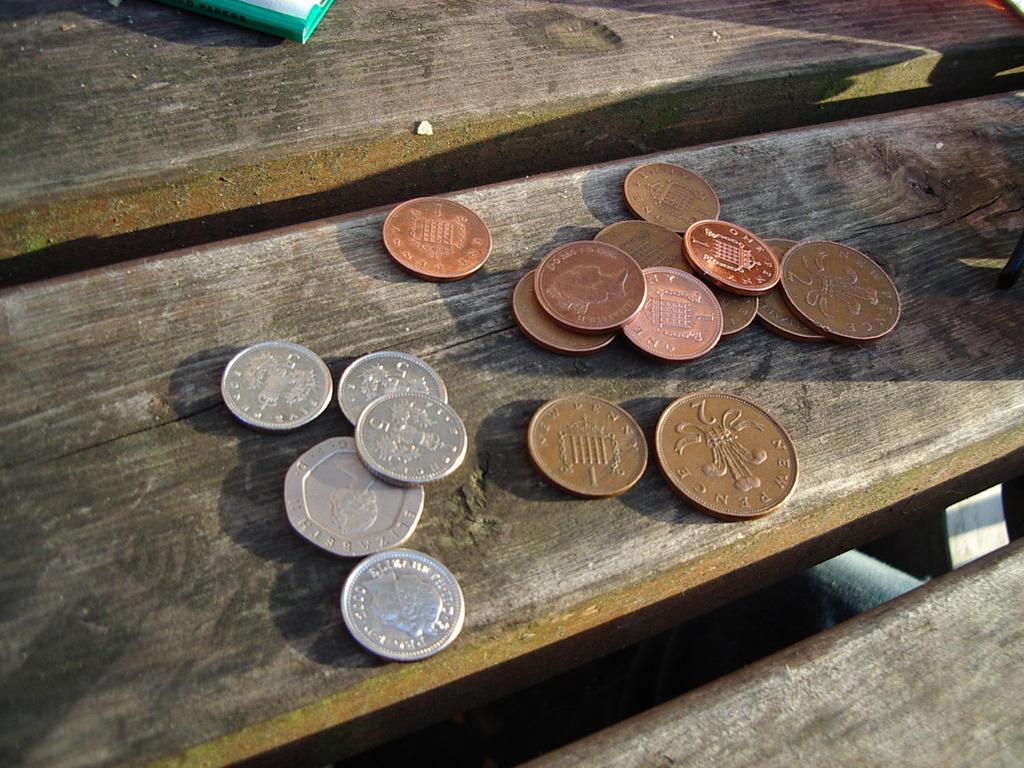<image>
Describe the image concisely. Some of the coins on the table say "new pence" on them. 